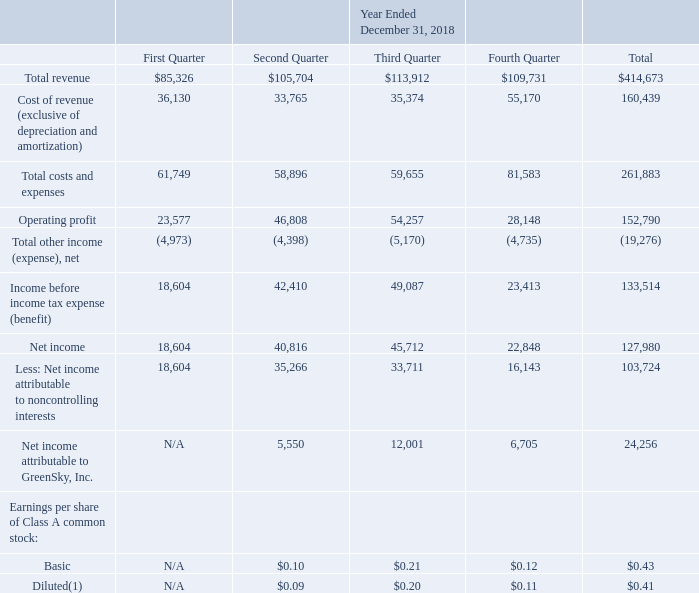GreenSky, Inc. NOTES TO CONSOLIDATED FINANCIAL STATEMENTS — (Continued) (United States Dollars in thousands, except per share data, unless otherwise stated)
Note 18. Quarterly Consolidated Results of Operations Data (Unaudited)
The following table sets forth our quarterly consolidated results of operations data for each of the eight quarters in the period ended December 31, 2019. GS Holdings is our predecessor for accounting purposes and, accordingly, amounts prior to the Reorganization Transactions and IPO represent the historical consolidated operations of GS Holdings and its subsidiaries. The amounts during the period from May 24, 2018 through December 31, 2018 represent those of consolidated GreenSky, Inc. and its subsidiaries. Basic and diluted earnings per share of Class A common stock is applicable only for the period from May 24, 2018 through December 31, 2018, which is the period following the Reorganization Transactions and IPO. Prior to the Reorganization Transactions and IPO, GreenSky, Inc. did not engage in any business or other activities except in connection with its formation and initial capitalization. See Note 1 for further information on our organization and see Note 2 for further information on our earnings per share.
(1) Year-to-date results may not agree to the sum of individual quarterly results due to rounding.
What was the cost of revenue in the fourth quarter?
Answer scale should be: thousand. 55,170. What was the total costs and expenses?
Answer scale should be: thousand. 261,883. What was the net total other income (expense)?
Answer scale should be: thousand. (19,276). How many quarters did basic earnings per share of Class A common stock exceed $0.20? Third quarter
answer: 1. What was the change in total costs and expenses between the second and third quarter?
Answer scale should be: thousand. 59,655-58,896
Answer: 759. What was the percentage change in the net income between the third and fourth quarter?
Answer scale should be: percent. (22,848-45,712)/45,712
Answer: -50.02. 